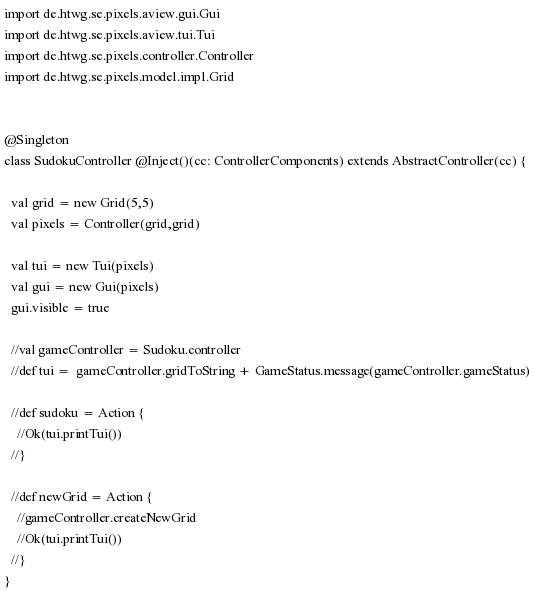<code> <loc_0><loc_0><loc_500><loc_500><_Scala_>import de.htwg.se.pixels.aview.gui.Gui
import de.htwg.se.pixels.aview.tui.Tui
import de.htwg.se.pixels.controller.Controller
import de.htwg.se.pixels.model.impl.Grid


@Singleton
class SudokuController @Inject()(cc: ControllerComponents) extends AbstractController(cc) {

  val grid = new Grid(5,5)
  val pixels = Controller(grid,grid)

  val tui = new Tui(pixels)
  val gui = new Gui(pixels)
  gui.visible = true

  //val gameController = Sudoku.controller
  //def tui =  gameController.gridToString + GameStatus.message(gameController.gameStatus)

  //def sudoku = Action {
    //Ok(tui.printTui())
  //}

  //def newGrid = Action {
    //gameController.createNewGrid
    //Ok(tui.printTui())
  //}
}</code> 